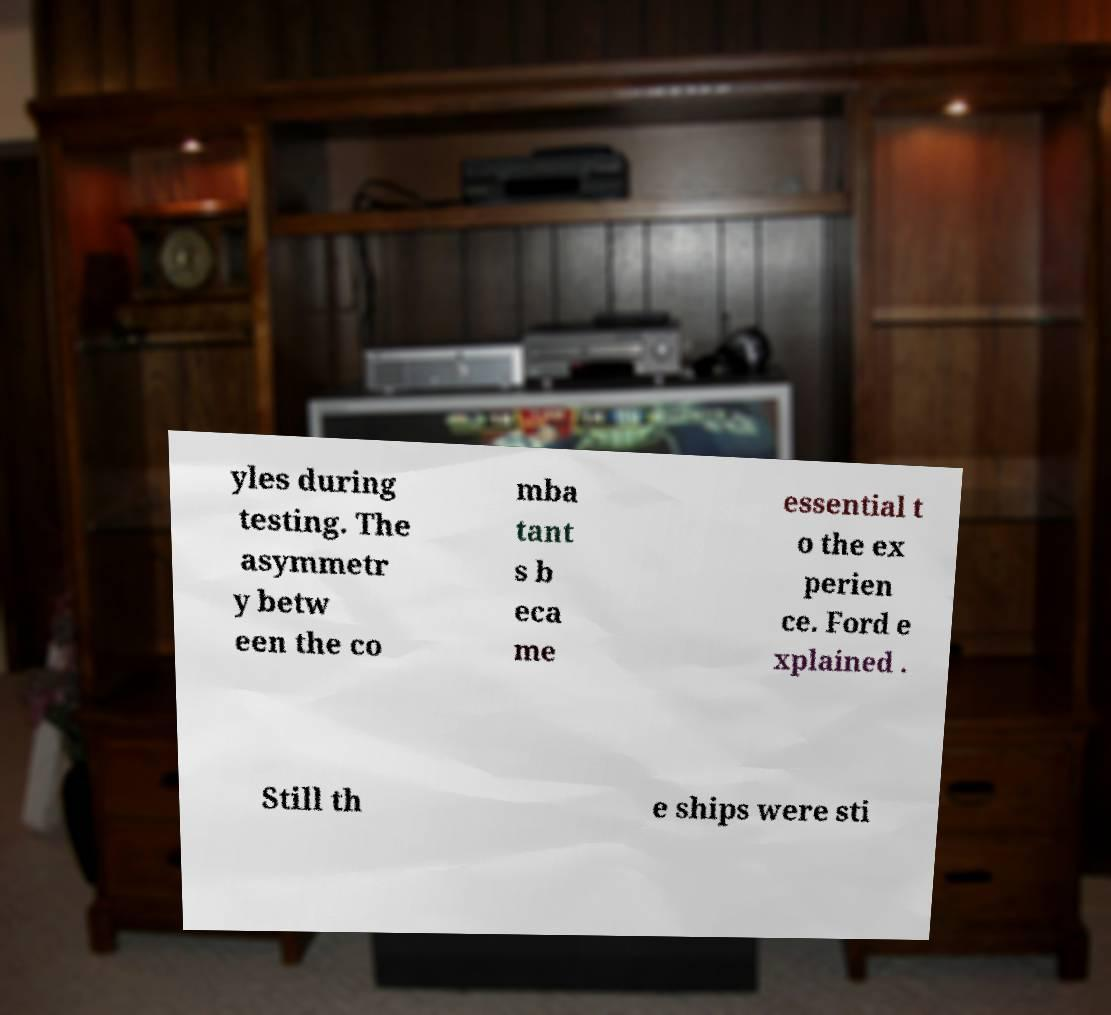Can you accurately transcribe the text from the provided image for me? yles during testing. The asymmetr y betw een the co mba tant s b eca me essential t o the ex perien ce. Ford e xplained . Still th e ships were sti 